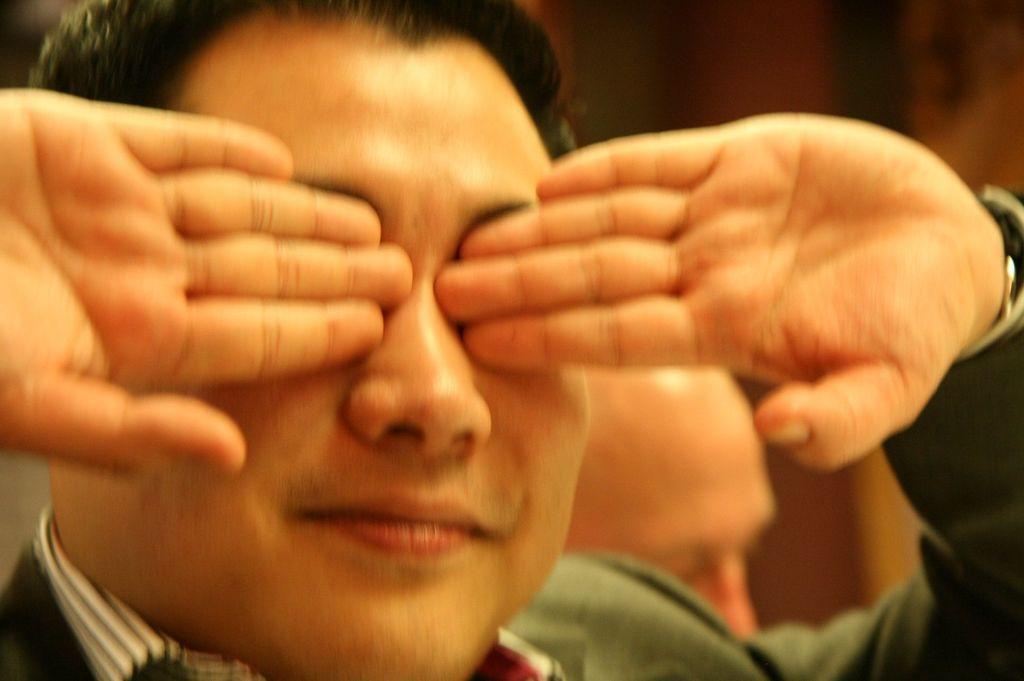How many people are in the image? There are two men in the image. What is one of the men doing with his hands? One of the men is covering his eyes with his hands. How many toads can be seen in the image? There are no toads present in the image. What type of care is being provided to the frogs in the image? There are no frogs present in the image, so no care is being provided. 